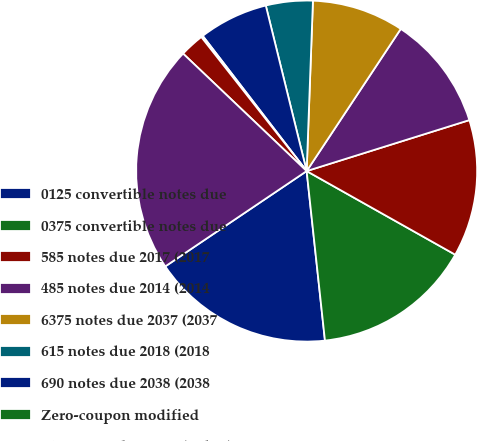Convert chart to OTSL. <chart><loc_0><loc_0><loc_500><loc_500><pie_chart><fcel>0125 convertible notes due<fcel>0375 convertible notes due<fcel>585 notes due 2017 (2017<fcel>485 notes due 2014 (2014<fcel>6375 notes due 2037 (2037<fcel>615 notes due 2018 (2018<fcel>690 notes due 2038 (2038<fcel>Zero-coupon modified<fcel>8125 notes due 2097 (Other)<fcel>Total borrowings<nl><fcel>17.27%<fcel>15.13%<fcel>12.99%<fcel>10.86%<fcel>8.72%<fcel>4.44%<fcel>6.58%<fcel>0.17%<fcel>2.3%<fcel>21.54%<nl></chart> 